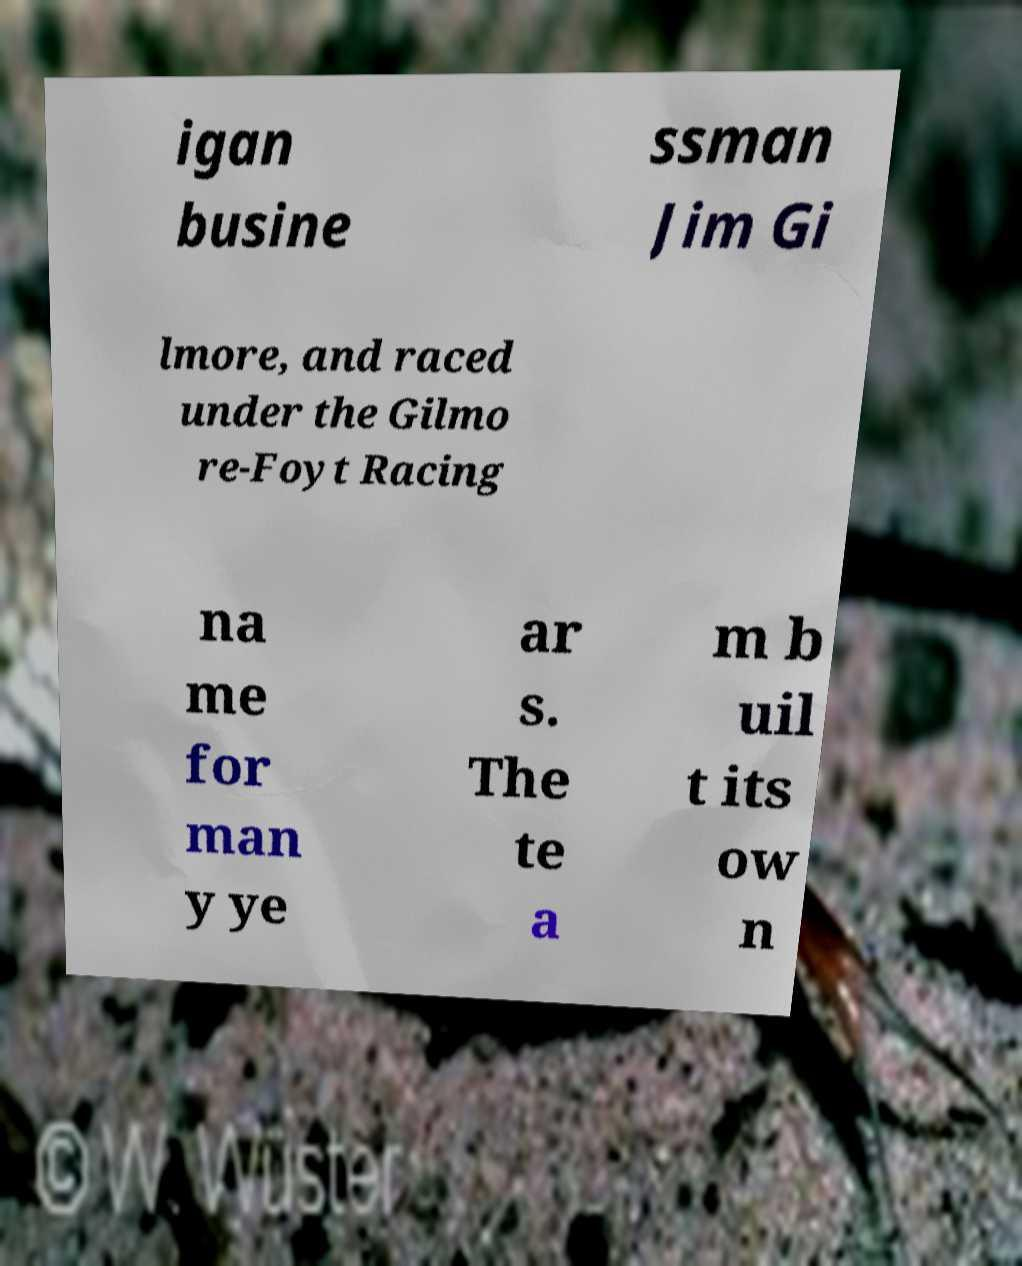What messages or text are displayed in this image? I need them in a readable, typed format. igan busine ssman Jim Gi lmore, and raced under the Gilmo re-Foyt Racing na me for man y ye ar s. The te a m b uil t its ow n 